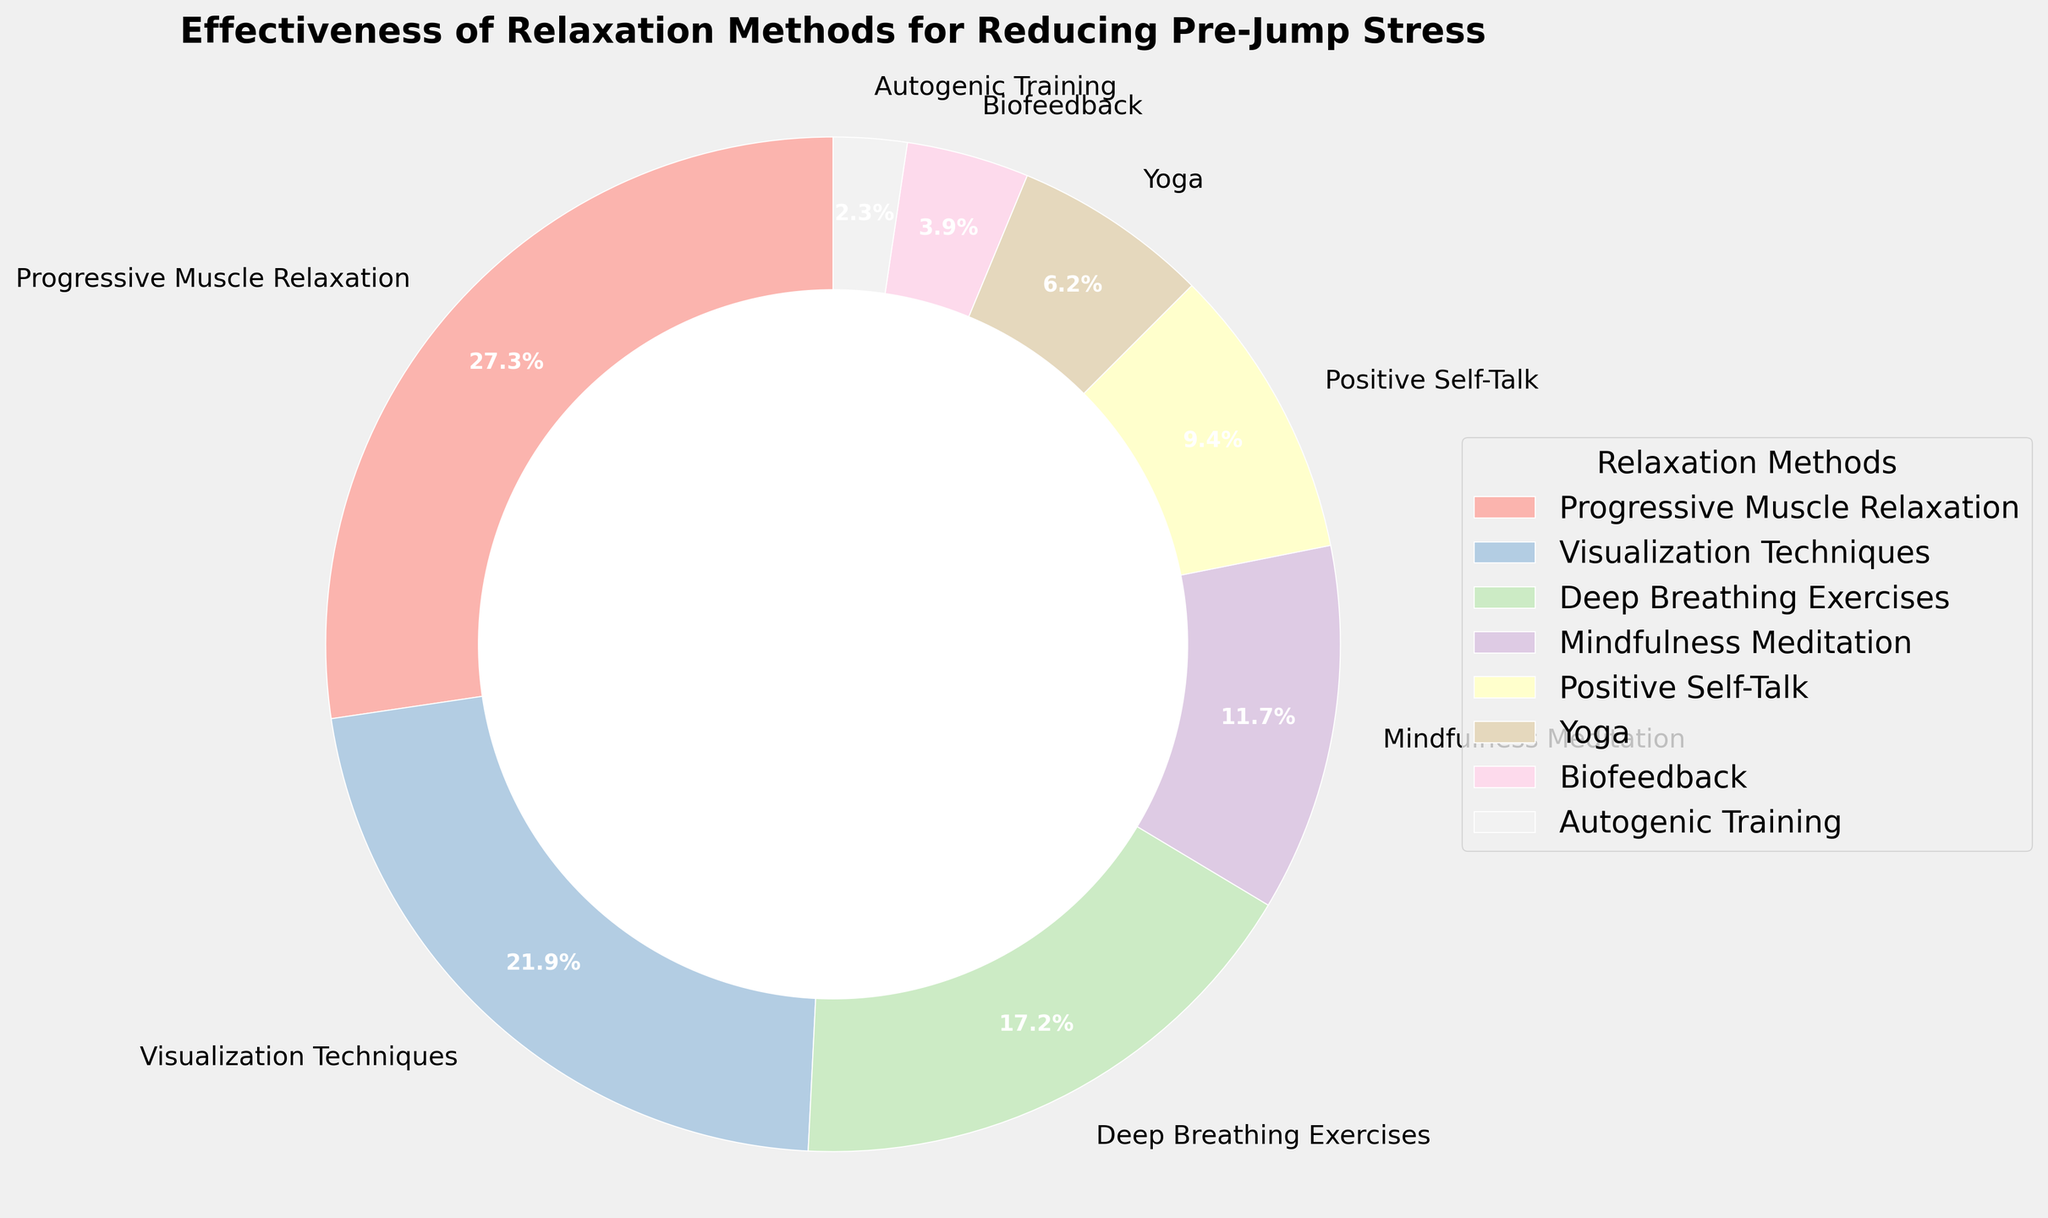Which relaxation method is rated as the most effective for reducing pre-jump stress? By observing the figure, Progressive Muscle Relaxation has the largest segment in the pie chart, indicating it's the most effective method.
Answer: Progressive Muscle Relaxation How much more effective is Visualization Techniques compared to Biofeedback? Visualization Techniques has an effectiveness of 28%, while Biofeedback has 5%. Subtracting the two gives 28% - 5% = 23%.
Answer: 23% What percentage of the total effectiveness do the top three methods account for? The top three methods are Progressive Muscle Relaxation (35%), Visualization Techniques (28%), and Deep Breathing Exercises (22%). Summing them up gives 35% + 28% + 22% = 85%.
Answer: 85% Which methods have an effectiveness rating of less than 10%? The methods with effectiveness ratings less than 10% are Yoga (8%), Biofeedback (5%), and Autogenic Training (3%), as these segments are visually smaller than the others.
Answer: Yoga, Biofeedback, Autogenic Training Are the combined effectiveness ratings of Positive Self-Talk and Yoga more effective than Deep Breathing Exercises alone? Positive Self-Talk has 12% and Yoga has 8%, which combined is 12% + 8% = 20%. Deep Breathing Exercises alone has 22%. So, 20% is less than 22%.
Answer: No What is the difference in effectiveness between the method rated second highest and the method rated least effective? The second highest is Visualization Techniques with 28%, and the least effective is Autogenic Training with 3%. The difference is 28% - 3% = 25%.
Answer: 25% Which method is represented by a light pink color in the pie chart? By matching the description of light pink to the segments, Visualization Techniques is shown as the light pink segment.
Answer: Visualization Techniques What is the total effectiveness percentage of methods rated higher than 20%? Methods rated higher than 20% are Progressive Muscle Relaxation (35%), Visualization Techniques (28%), and Deep Breathing Exercises (22%). Their total effectiveness is 35% + 28% + 22% = 85%.
Answer: 85% How many methods have an effectiveness rating greater than Mindfulness Meditation? Mindfulness Meditation has a rating of 15%. The methods with higher ratings are Progressive Muscle Relaxation (35%), Visualization Techniques (28%), Deep Breathing Exercises (22%), and Positive Self-Talk (12%). Thus, there are 3 methods.
Answer: 3 